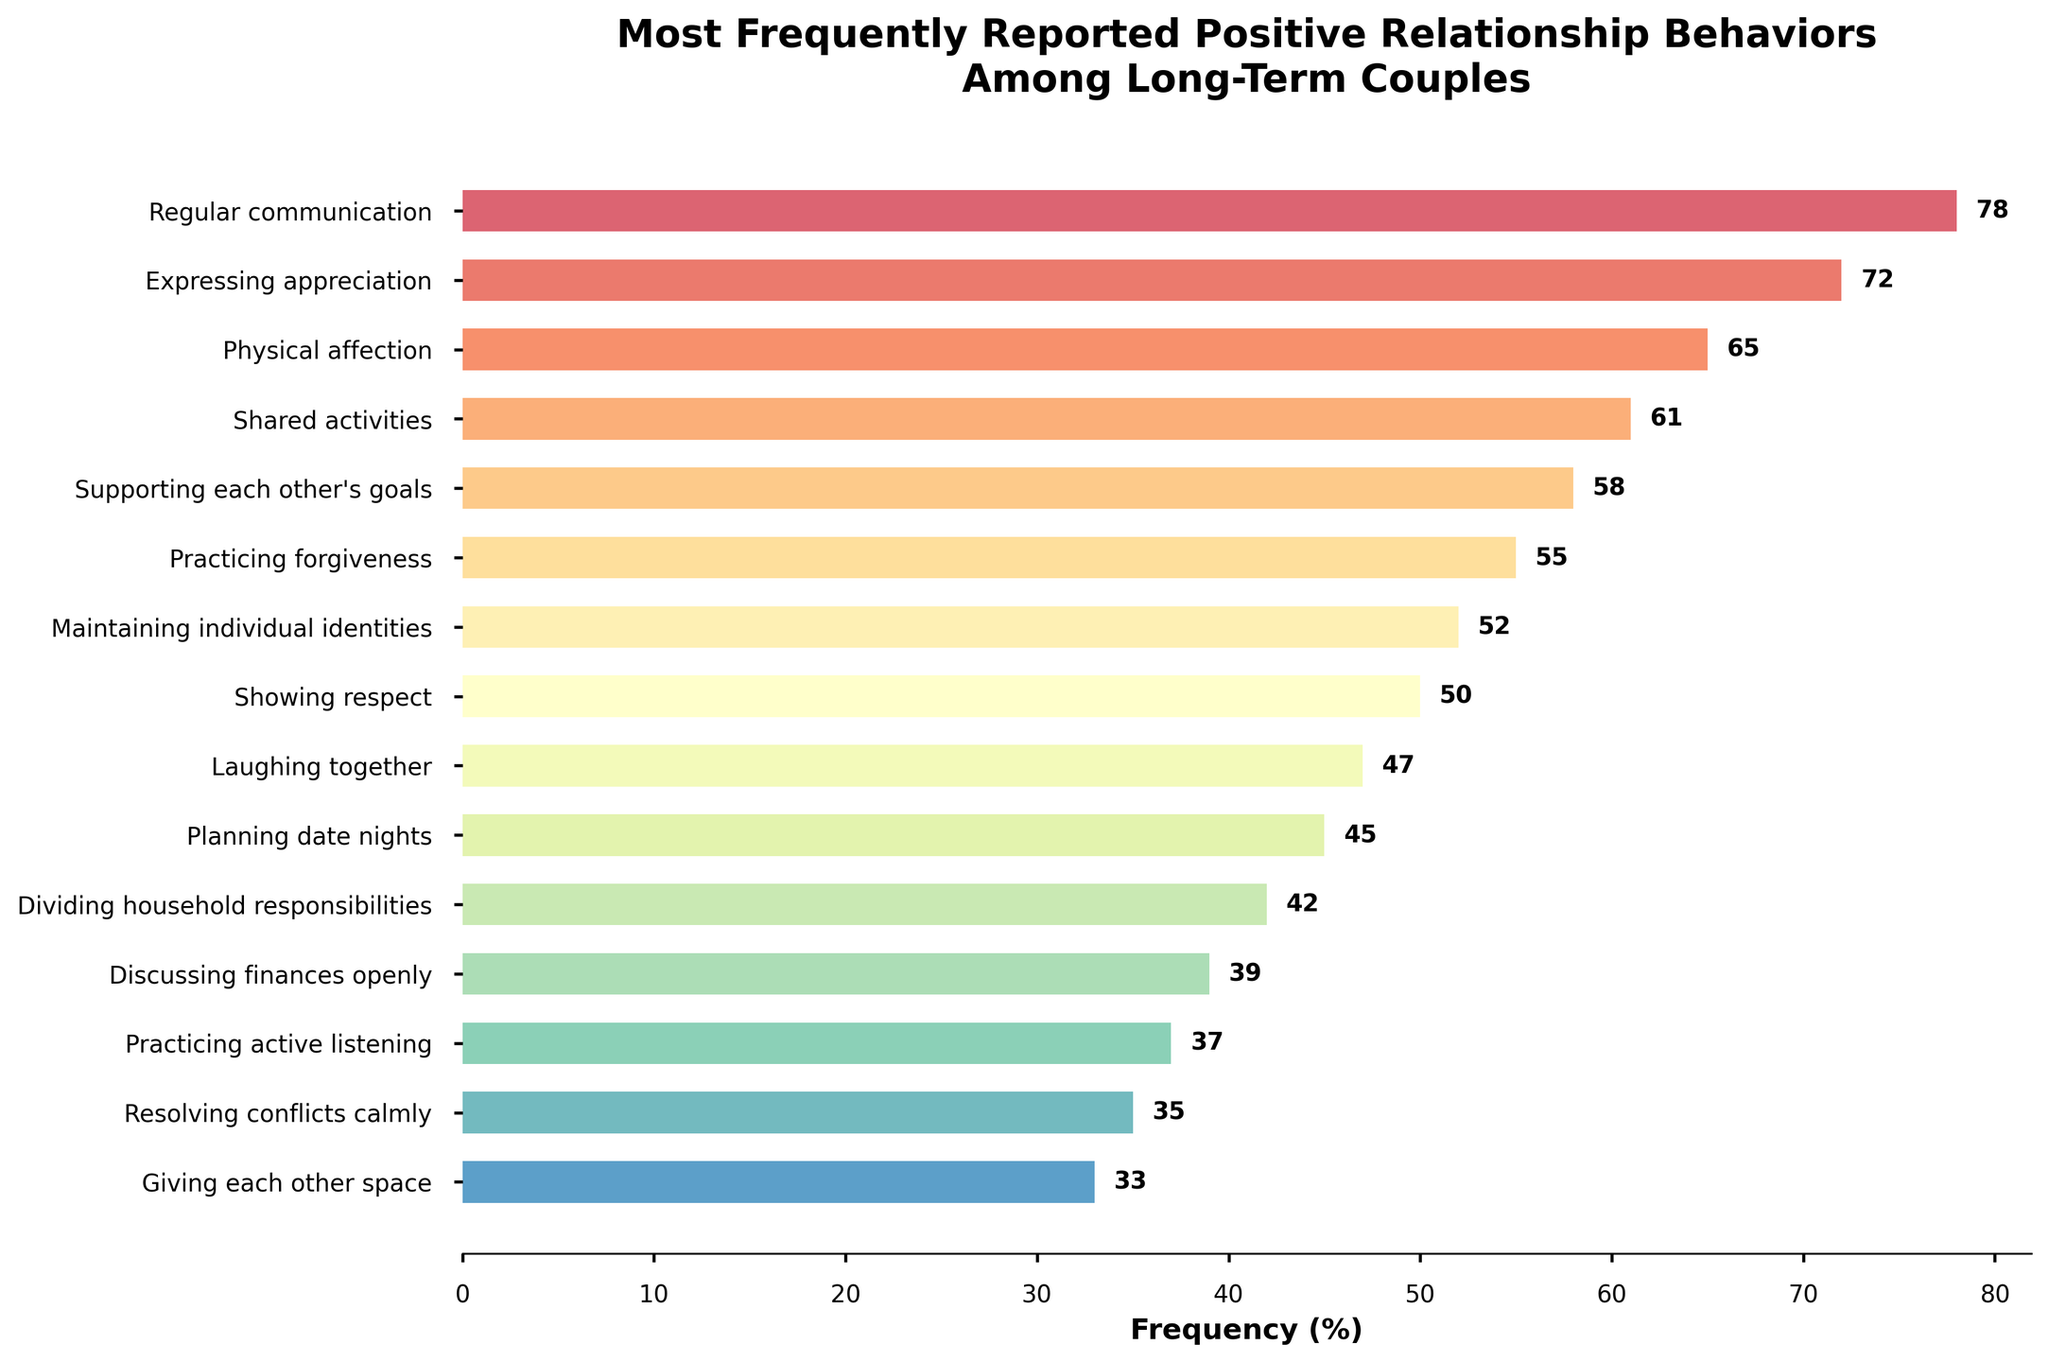What are the top three most frequently reported positive relationship behaviors? Identify the top three behaviors from the bar chart by their frequency percentage, which are the longest bars. These are "Regular communication" (78%), "Expressing appreciation" (72%), and "Physical affection" (65%).
Answer: Regular communication, Expressing appreciation, Physical affection Which behavior is reported more frequently: "Laughing together" or "Showing respect"? Compare the frequencies of the two behaviors. "Laughing together" has a frequency of 47%, while "Showing respect" has a frequency of 50%.
Answer: Showing respect How many behaviors have a frequency above 50%? Count the number of behaviors with a bar length representing a frequency greater than 50%. These are "Regular communication" (78%), "Expressing appreciation" (72%), "Physical affection" (65%), "Shared activities" (61%), "Supporting each other's goals" (58%), and "Practicing forgiveness" (55%), amounting to 6 behaviors.
Answer: 6 What is the average frequency of the three least frequently reported behaviors? Identify the three least reported behaviors: "Giving each other space" (33%), "Resolving conflicts calmly" (35%), and "Practicing active listening" (37%). Then calculate the average: (33 + 35 + 37) / 3 = 35.
Answer: 35 Which behavior is reported slightly less frequently than "Practicing forgiveness"? Find the frequencies close to "Practicing forgiveness" (55%). The behavior reported slightly less frequently is "Maintaining individual identities" with a frequency of 52%.
Answer: Maintaining individual identities Which has a higher frequency: "Expressing appreciation" or the combined frequency of "Discussing finances openly" and "Dividing household responsibilities"? Compare the frequency of "Expressing appreciation" (72%) against the combined frequency of "Discussing finances openly" (39%) and "Dividing household responsibilities" (42%). The combined frequency is 39 + 42 = 81%, which is higher than 72%.
Answer: Combined frequency of Discussing finances openly and Dividing household responsibilities Which behaviors have a frequency below 40%? Identify the bars with frequencies below 40%. These are "Discussing finances openly" (39%), "Practicing active listening" (37%), "Resolving conflicts calmly" (35%), and "Giving each other space" (33%).
Answer: Discussing finances openly, Practicing active listening, Resolving conflicts calmly, Giving each other space What is the difference in frequency between "Supporting each other's goals" and "Planning date nights"? Subtract the frequency of "Planning date nights" (45%) from "Supporting each other's goals" (58%). The difference is 58 - 45 = 13.
Answer: 13 